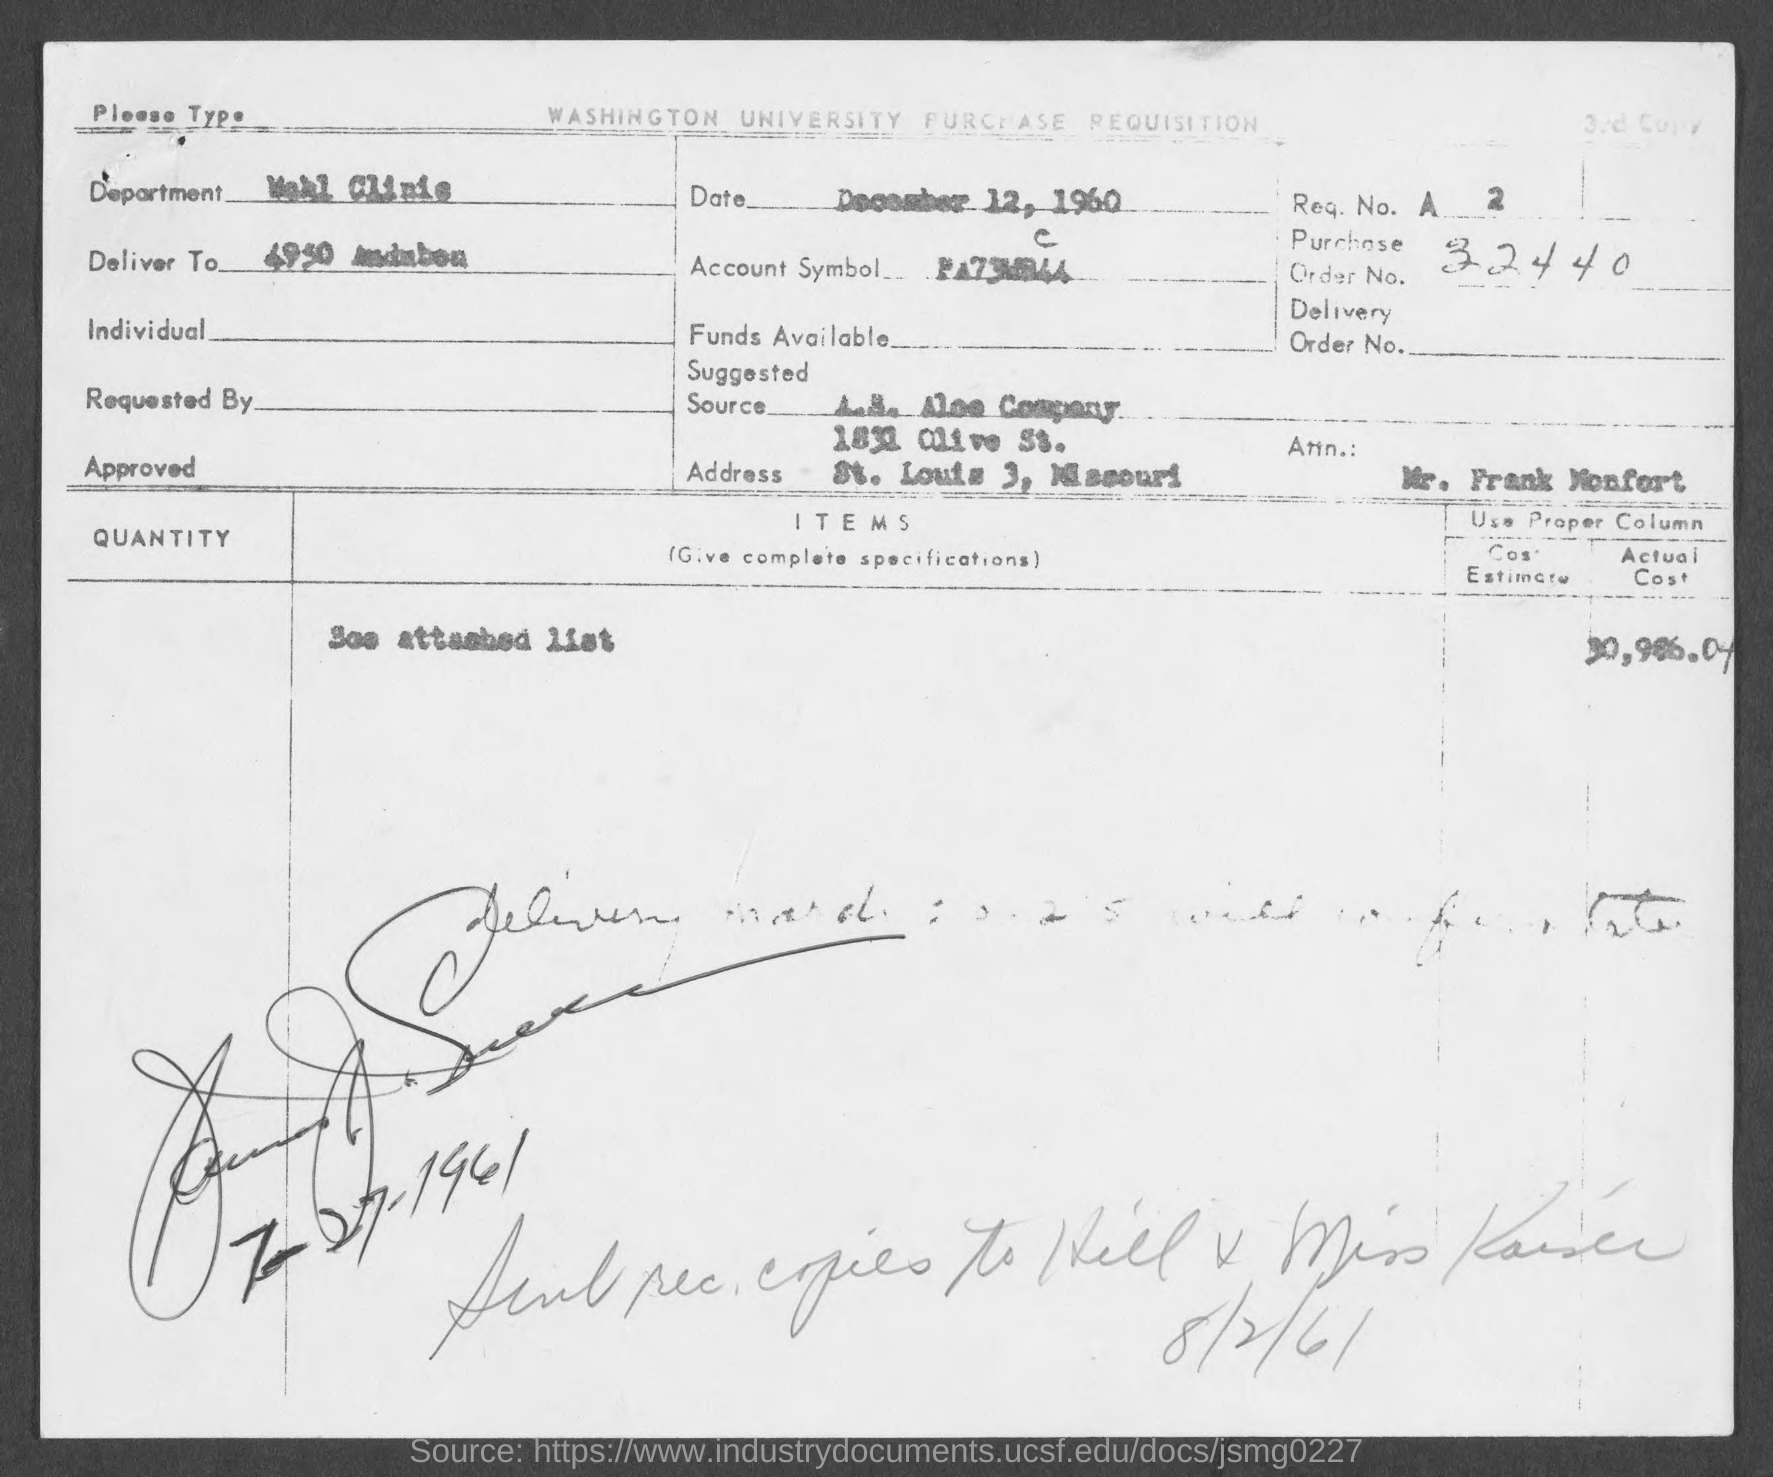What is the purchase order no.?
Give a very brief answer. 32440. What is date in the form?
Your answer should be very brief. December 12, 1960. 